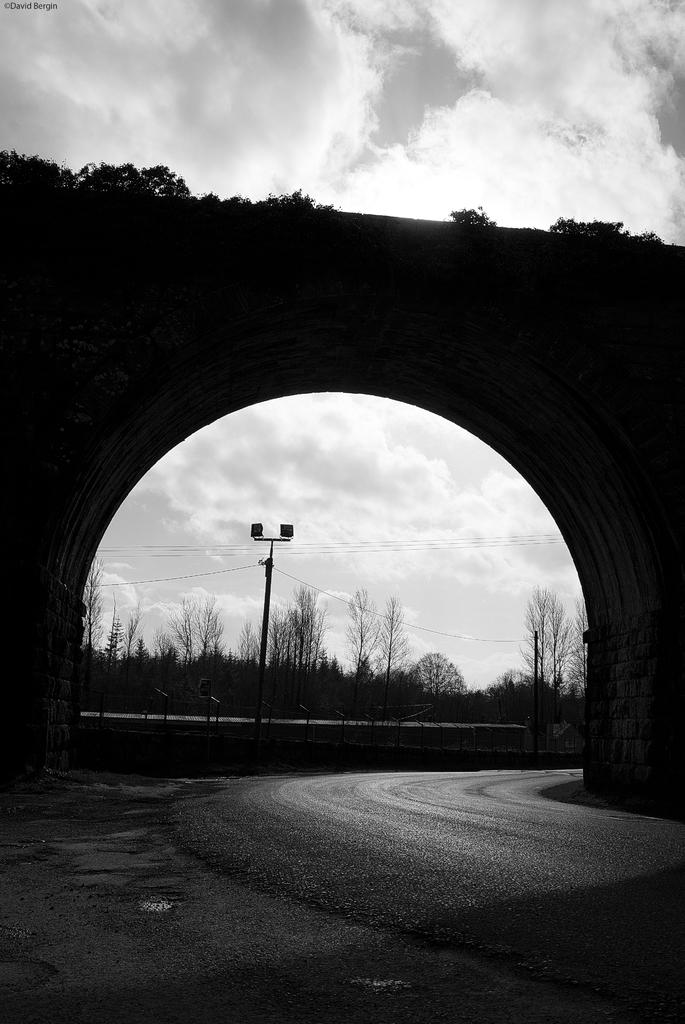What is the main structure in the center of the image? There is a bridge in the center of the image. What can be seen on the bridge? There are plants on the bridge. What type of vegetation is visible in the background of the image? There are trees in the background of the image. What else can be seen in the background of the image? There is a pole in the background of the image. How would you describe the weather in the image? The sky is cloudy in the image. How many horses are competing in the race on the bridge? There are no horses or races present in the image; it features a bridge with plants and a cloudy sky. 